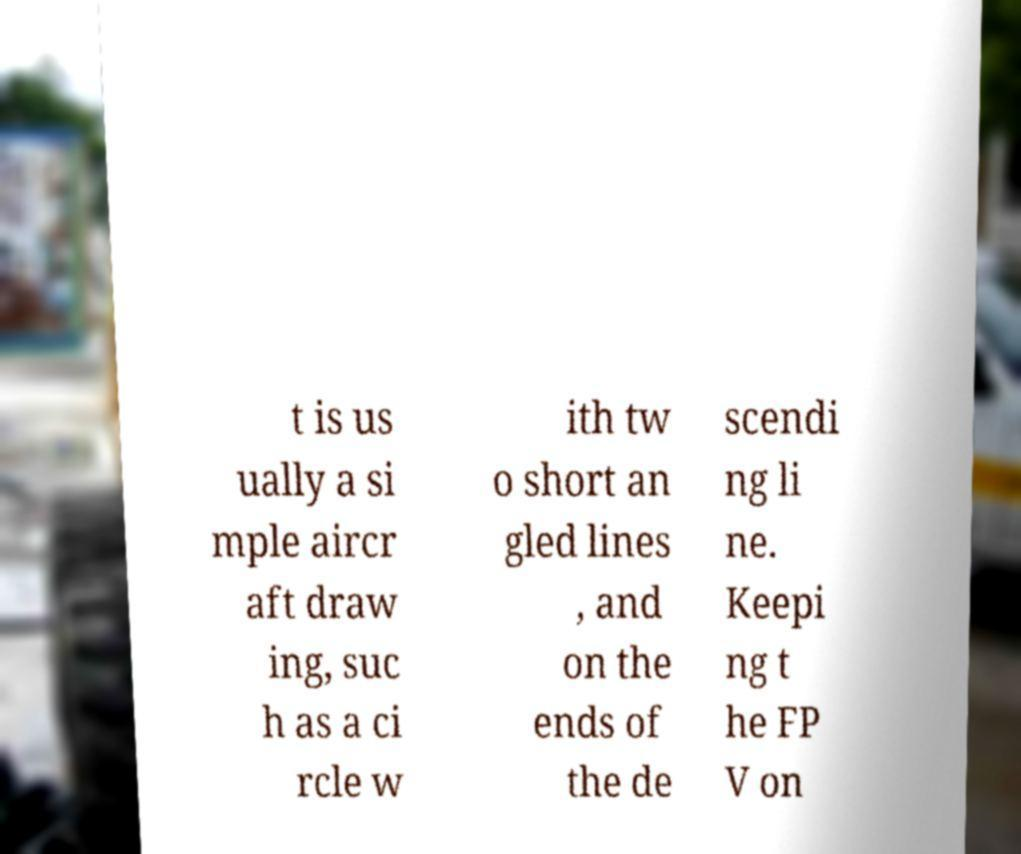Please identify and transcribe the text found in this image. t is us ually a si mple aircr aft draw ing, suc h as a ci rcle w ith tw o short an gled lines , and on the ends of the de scendi ng li ne. Keepi ng t he FP V on 